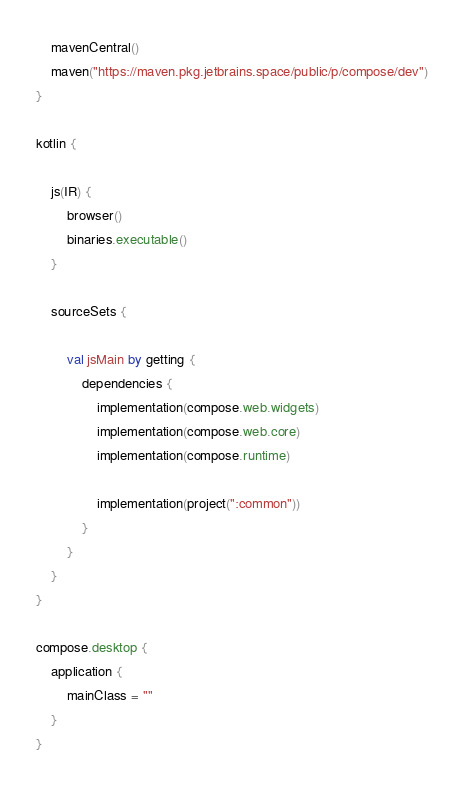<code> <loc_0><loc_0><loc_500><loc_500><_Kotlin_>    mavenCentral()
    maven("https://maven.pkg.jetbrains.space/public/p/compose/dev")
}

kotlin {

    js(IR) {
        browser()
        binaries.executable()
    }

    sourceSets {

        val jsMain by getting {
            dependencies {
                implementation(compose.web.widgets)
                implementation(compose.web.core)
                implementation(compose.runtime)

                implementation(project(":common"))
            }
        }
    }
}

compose.desktop {
    application {
        mainClass = ""
    }
}

</code> 